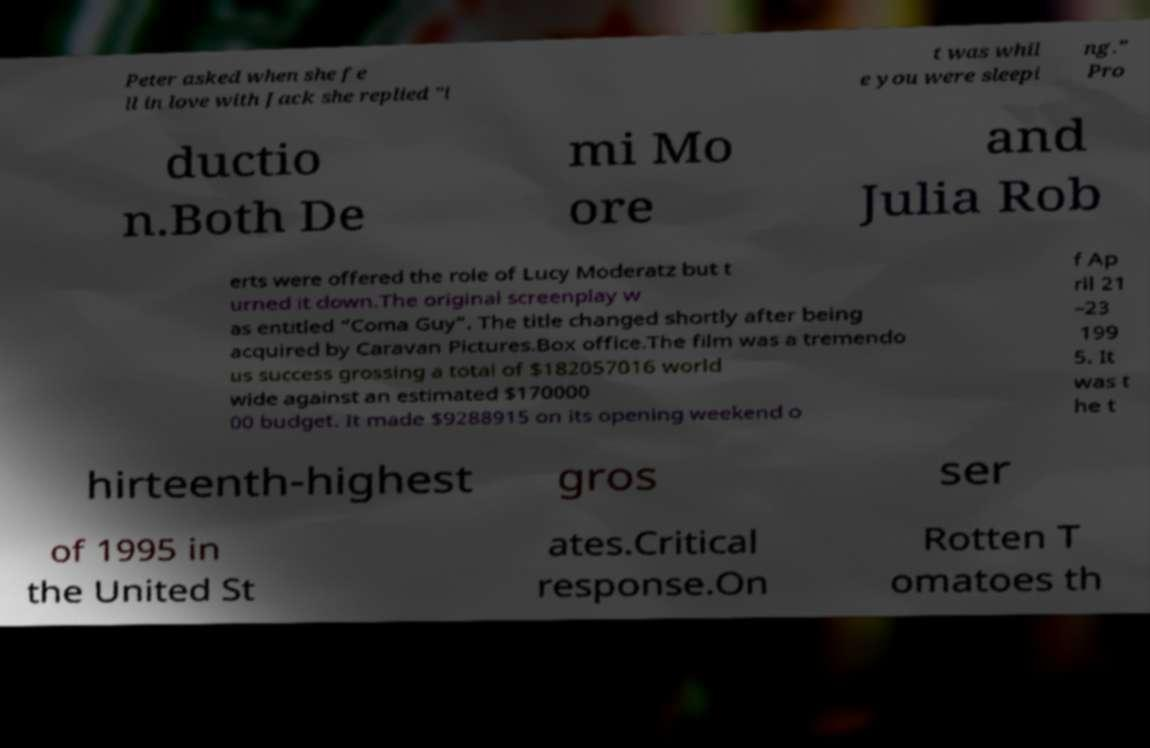Can you accurately transcribe the text from the provided image for me? Peter asked when she fe ll in love with Jack she replied "i t was whil e you were sleepi ng." Pro ductio n.Both De mi Mo ore and Julia Rob erts were offered the role of Lucy Moderatz but t urned it down.The original screenplay w as entitled “Coma Guy”. The title changed shortly after being acquired by Caravan Pictures.Box office.The film was a tremendo us success grossing a total of $182057016 world wide against an estimated $170000 00 budget. It made $9288915 on its opening weekend o f Ap ril 21 –23 199 5. It was t he t hirteenth-highest gros ser of 1995 in the United St ates.Critical response.On Rotten T omatoes th 